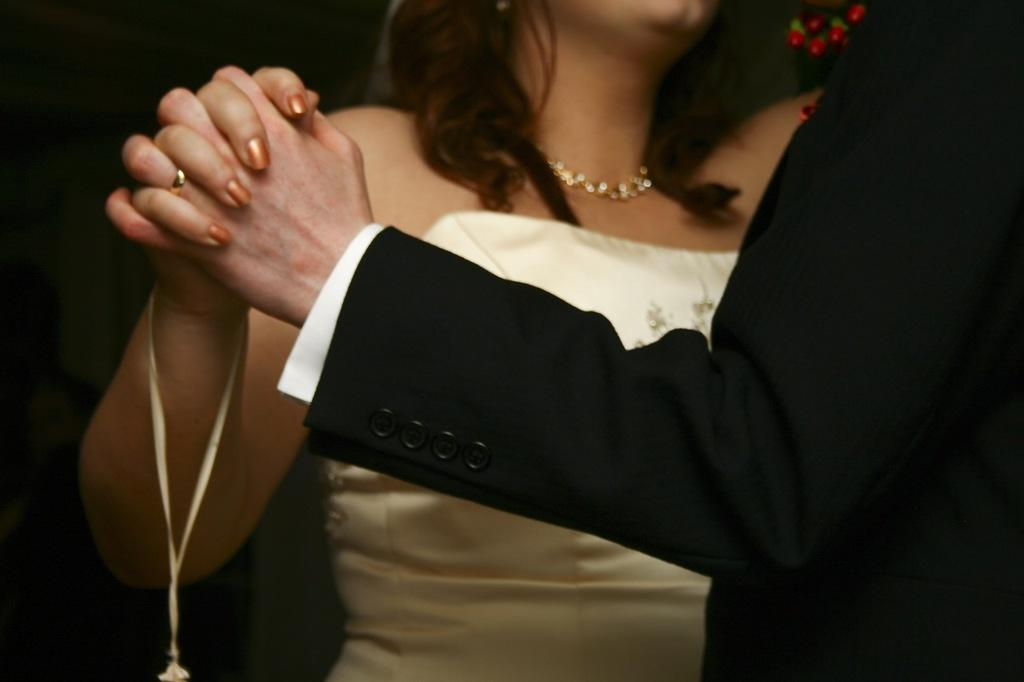Who is present in the image? There is a man and a woman in the image. What are the man and woman doing in the image? The man and woman are holding hands in the image. What else can be seen in the image besides the man and woman? There are flowers in the image. Where is the giraffe in the image? There is no giraffe present in the image. What adjustment did the man make to the woman's hand before holding it? The provided facts do not mention any adjustments made by the man before holding the woman's hand. 